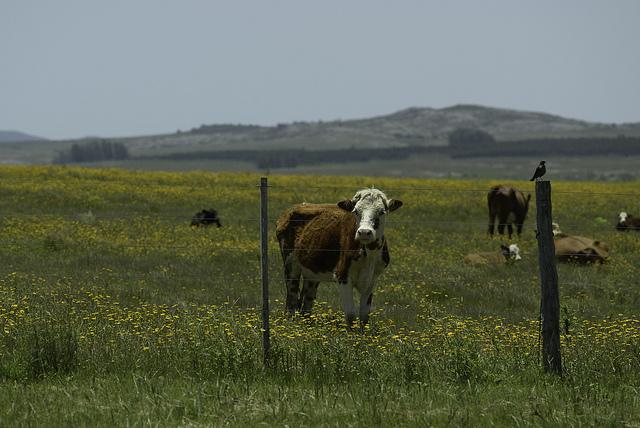Is the cow behind a fence?
Keep it brief. Yes. What is the bird on?
Quick response, please. Fence post. What are these animals?
Keep it brief. Cows. Are these farm animals?
Concise answer only. Yes. Are these animals in a farm?
Short answer required. Yes. What animal is facing the camera?
Answer briefly. Cow. Is that a second cow or a person?
Answer briefly. Cow. How many cows are in the picture?
Short answer required. 6. Is the mountain tall?
Quick response, please. No. 